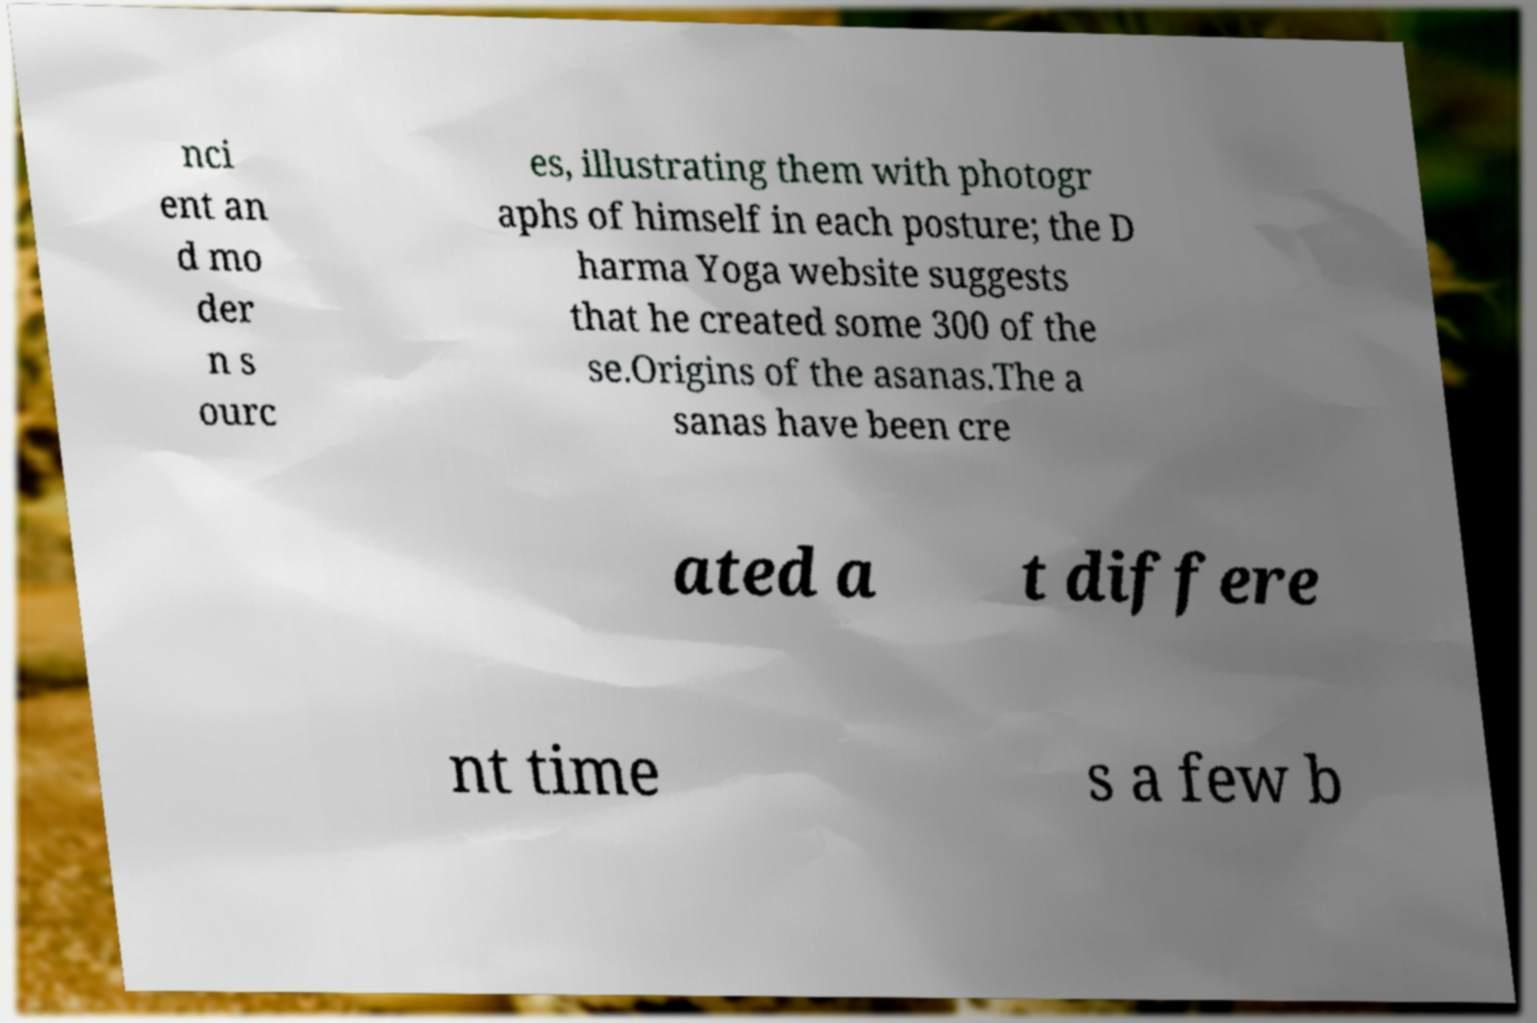Could you assist in decoding the text presented in this image and type it out clearly? nci ent an d mo der n s ourc es, illustrating them with photogr aphs of himself in each posture; the D harma Yoga website suggests that he created some 300 of the se.Origins of the asanas.The a sanas have been cre ated a t differe nt time s a few b 